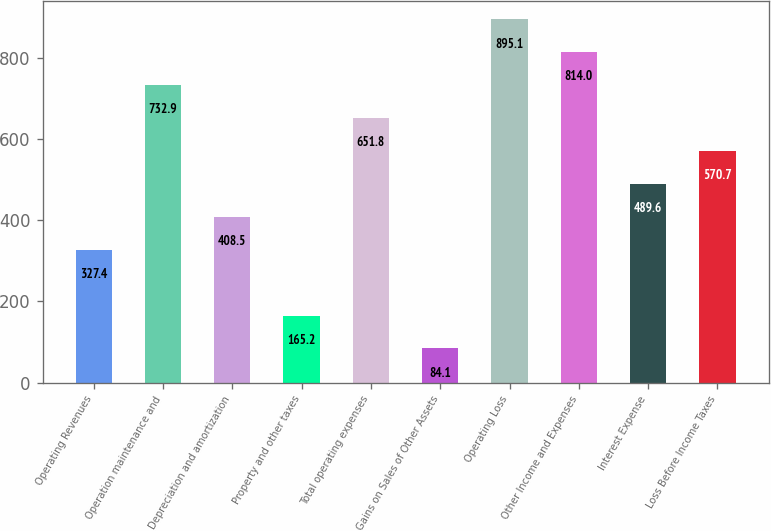<chart> <loc_0><loc_0><loc_500><loc_500><bar_chart><fcel>Operating Revenues<fcel>Operation maintenance and<fcel>Depreciation and amortization<fcel>Property and other taxes<fcel>Total operating expenses<fcel>Gains on Sales of Other Assets<fcel>Operating Loss<fcel>Other Income and Expenses<fcel>Interest Expense<fcel>Loss Before Income Taxes<nl><fcel>327.4<fcel>732.9<fcel>408.5<fcel>165.2<fcel>651.8<fcel>84.1<fcel>895.1<fcel>814<fcel>489.6<fcel>570.7<nl></chart> 